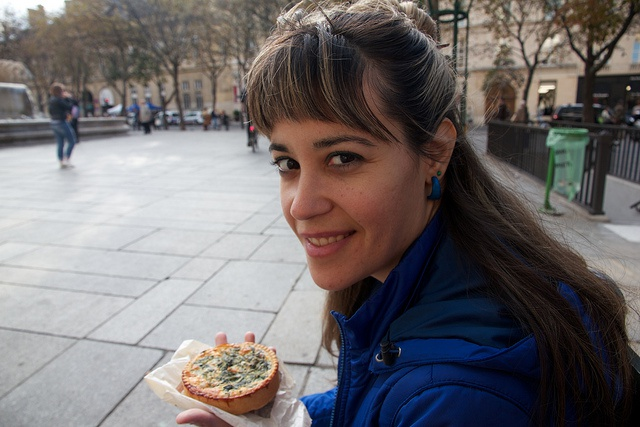Describe the objects in this image and their specific colors. I can see people in white, black, maroon, navy, and brown tones, people in white, gray, black, darkblue, and navy tones, car in white, black, gray, and darkgray tones, people in white, gray, black, and darkblue tones, and car in white, gray, and darkgray tones in this image. 